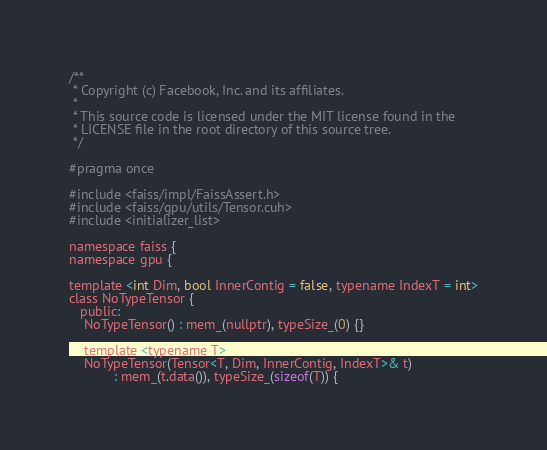Convert code to text. <code><loc_0><loc_0><loc_500><loc_500><_Cuda_>/**
 * Copyright (c) Facebook, Inc. and its affiliates.
 *
 * This source code is licensed under the MIT license found in the
 * LICENSE file in the root directory of this source tree.
 */

#pragma once

#include <faiss/impl/FaissAssert.h>
#include <faiss/gpu/utils/Tensor.cuh>
#include <initializer_list>

namespace faiss {
namespace gpu {

template <int Dim, bool InnerContig = false, typename IndexT = int>
class NoTypeTensor {
   public:
    NoTypeTensor() : mem_(nullptr), typeSize_(0) {}

    template <typename T>
    NoTypeTensor(Tensor<T, Dim, InnerContig, IndexT>& t)
            : mem_(t.data()), typeSize_(sizeof(T)) {</code> 